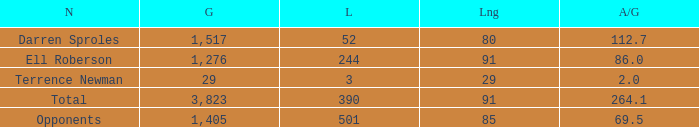What's the sum of all average yards gained when the gained yards is under 1,276 and lost more than 3 yards? None. 